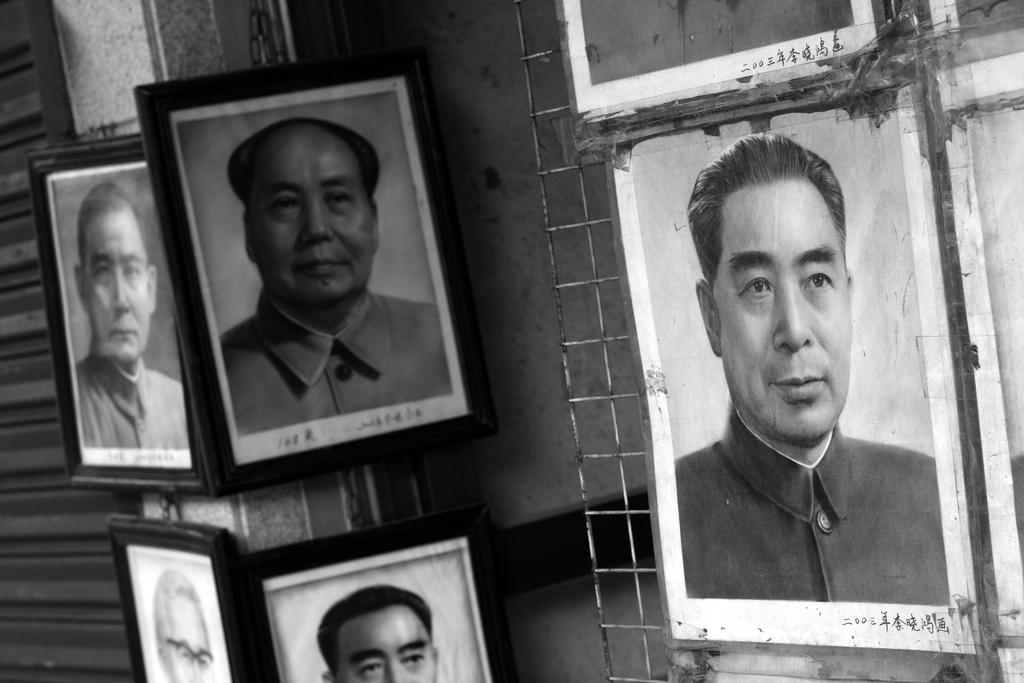What can be seen hanging on the wall in the image? There are photo frames on the wall in the image. What type of material is present in the image? There is a metal mesh in the image. How many fingers can be seen in the image? There are no fingers visible in the image. What type of destruction is depicted in the image? There is no destruction depicted in the image; it features photo frames on the wall and a metal mesh. 